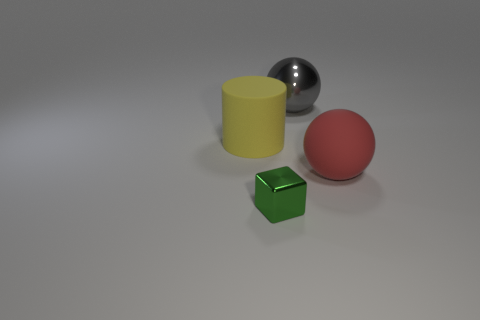Add 4 large red metallic cylinders. How many objects exist? 8 Add 4 red rubber cylinders. How many red rubber cylinders exist? 4 Subtract 0 blue cylinders. How many objects are left? 4 Subtract all tiny cubes. Subtract all red balls. How many objects are left? 2 Add 1 big yellow matte cylinders. How many big yellow matte cylinders are left? 2 